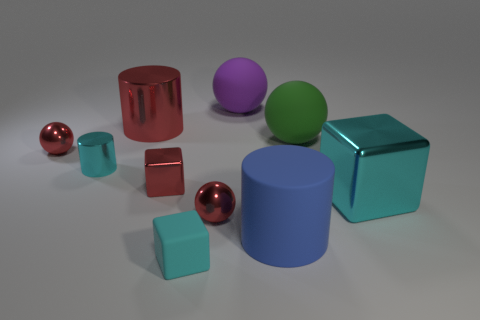What colors are the objects in the image? The objects present a variety of colors including red, cyan, purple, and green, along with the metallic luster of the spheres that almost resembles copper. Is there any pattern or formation to how the objects are arranged? There does not appear to be a specific pattern to the arrangement of the objects; they are placed somewhat randomly on the surface. 